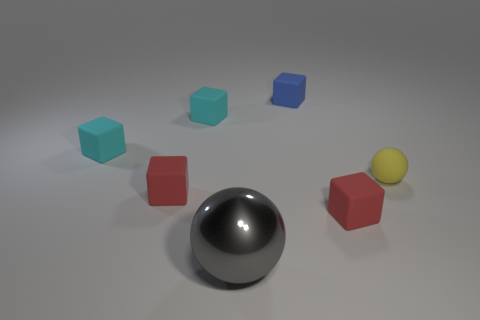How many cyan cubes must be subtracted to get 1 cyan cubes? 1 Add 3 blue blocks. How many objects exist? 10 Subtract all cubes. How many objects are left? 2 Add 5 small yellow balls. How many small yellow balls are left? 6 Add 4 yellow rubber spheres. How many yellow rubber spheres exist? 5 Subtract 0 gray cylinders. How many objects are left? 7 Subtract all blue cubes. Subtract all big metallic objects. How many objects are left? 5 